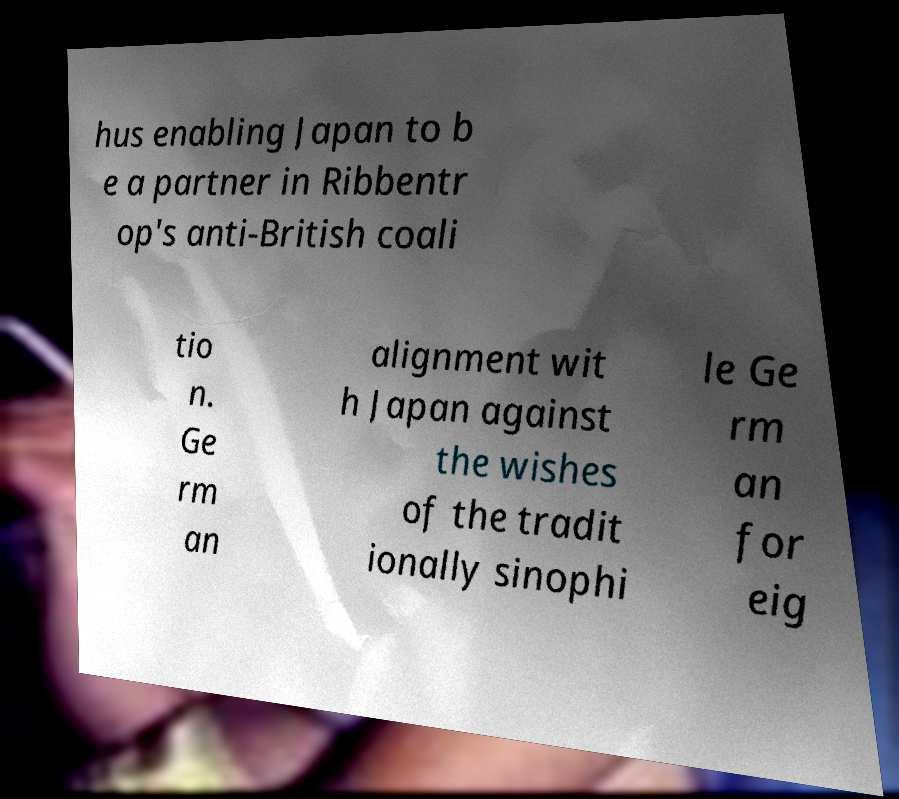There's text embedded in this image that I need extracted. Can you transcribe it verbatim? hus enabling Japan to b e a partner in Ribbentr op's anti-British coali tio n. Ge rm an alignment wit h Japan against the wishes of the tradit ionally sinophi le Ge rm an for eig 